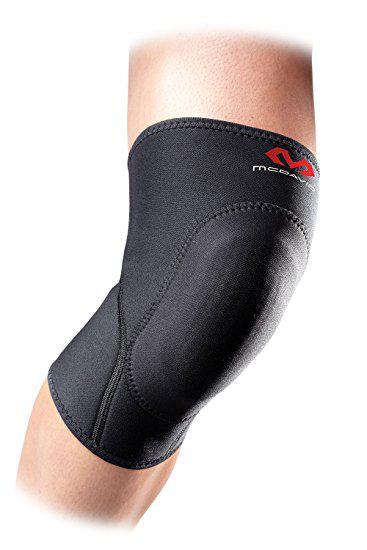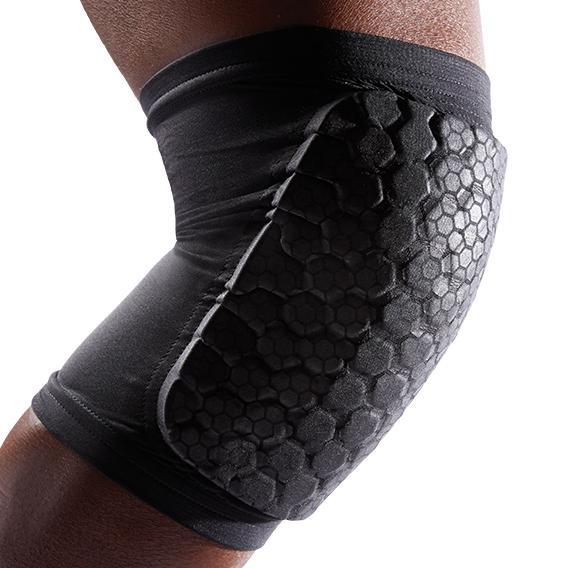The first image is the image on the left, the second image is the image on the right. For the images shown, is this caption "one of the images is one a black background" true? Answer yes or no. No. The first image is the image on the left, the second image is the image on the right. Given the left and right images, does the statement "Exactly two knee braces are positioned on legs to show their proper use." hold true? Answer yes or no. Yes. 